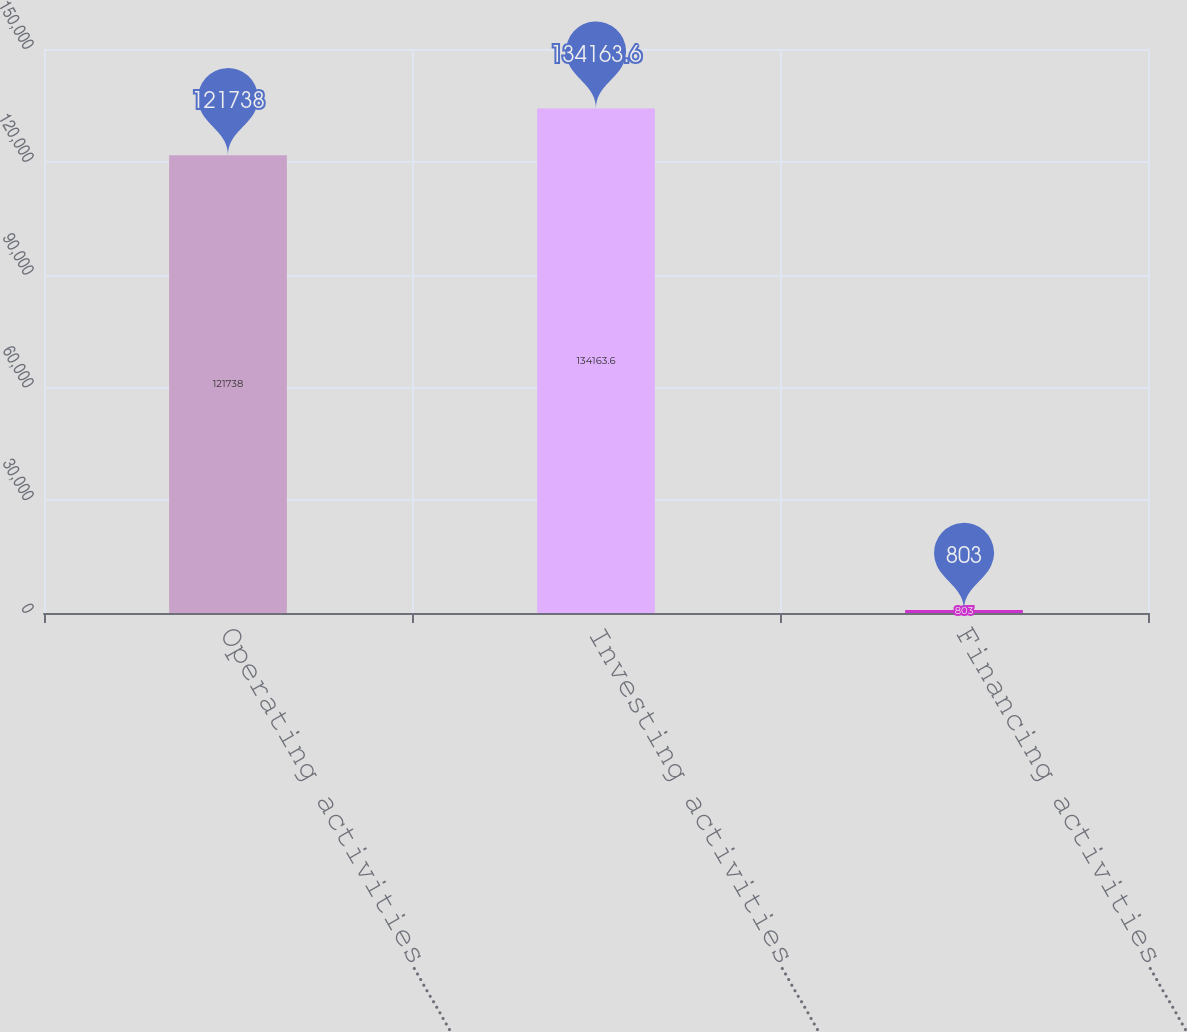<chart> <loc_0><loc_0><loc_500><loc_500><bar_chart><fcel>Operating activities…………………………<fcel>Investing activities…………………………<fcel>Financing activities…………………………<nl><fcel>121738<fcel>134164<fcel>803<nl></chart> 